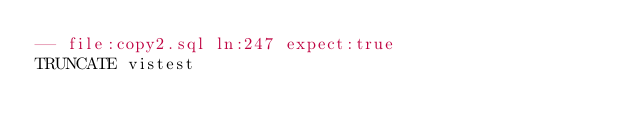Convert code to text. <code><loc_0><loc_0><loc_500><loc_500><_SQL_>-- file:copy2.sql ln:247 expect:true
TRUNCATE vistest
</code> 